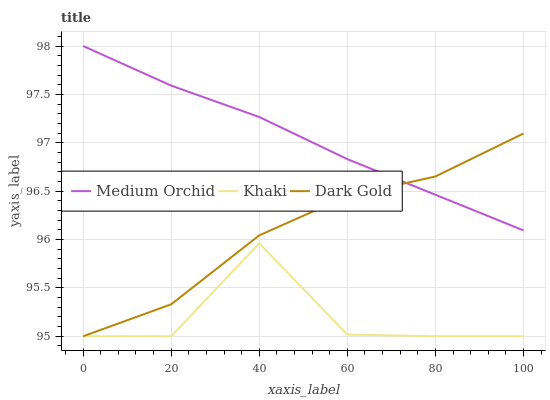Does Khaki have the minimum area under the curve?
Answer yes or no. Yes. Does Medium Orchid have the maximum area under the curve?
Answer yes or no. Yes. Does Dark Gold have the minimum area under the curve?
Answer yes or no. No. Does Dark Gold have the maximum area under the curve?
Answer yes or no. No. Is Medium Orchid the smoothest?
Answer yes or no. Yes. Is Khaki the roughest?
Answer yes or no. Yes. Is Dark Gold the smoothest?
Answer yes or no. No. Is Dark Gold the roughest?
Answer yes or no. No. Does Khaki have the lowest value?
Answer yes or no. Yes. Does Medium Orchid have the highest value?
Answer yes or no. Yes. Does Dark Gold have the highest value?
Answer yes or no. No. Is Khaki less than Medium Orchid?
Answer yes or no. Yes. Is Medium Orchid greater than Khaki?
Answer yes or no. Yes. Does Dark Gold intersect Khaki?
Answer yes or no. Yes. Is Dark Gold less than Khaki?
Answer yes or no. No. Is Dark Gold greater than Khaki?
Answer yes or no. No. Does Khaki intersect Medium Orchid?
Answer yes or no. No. 